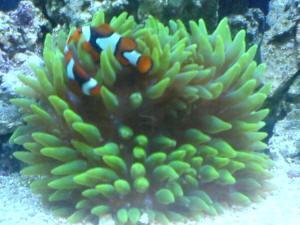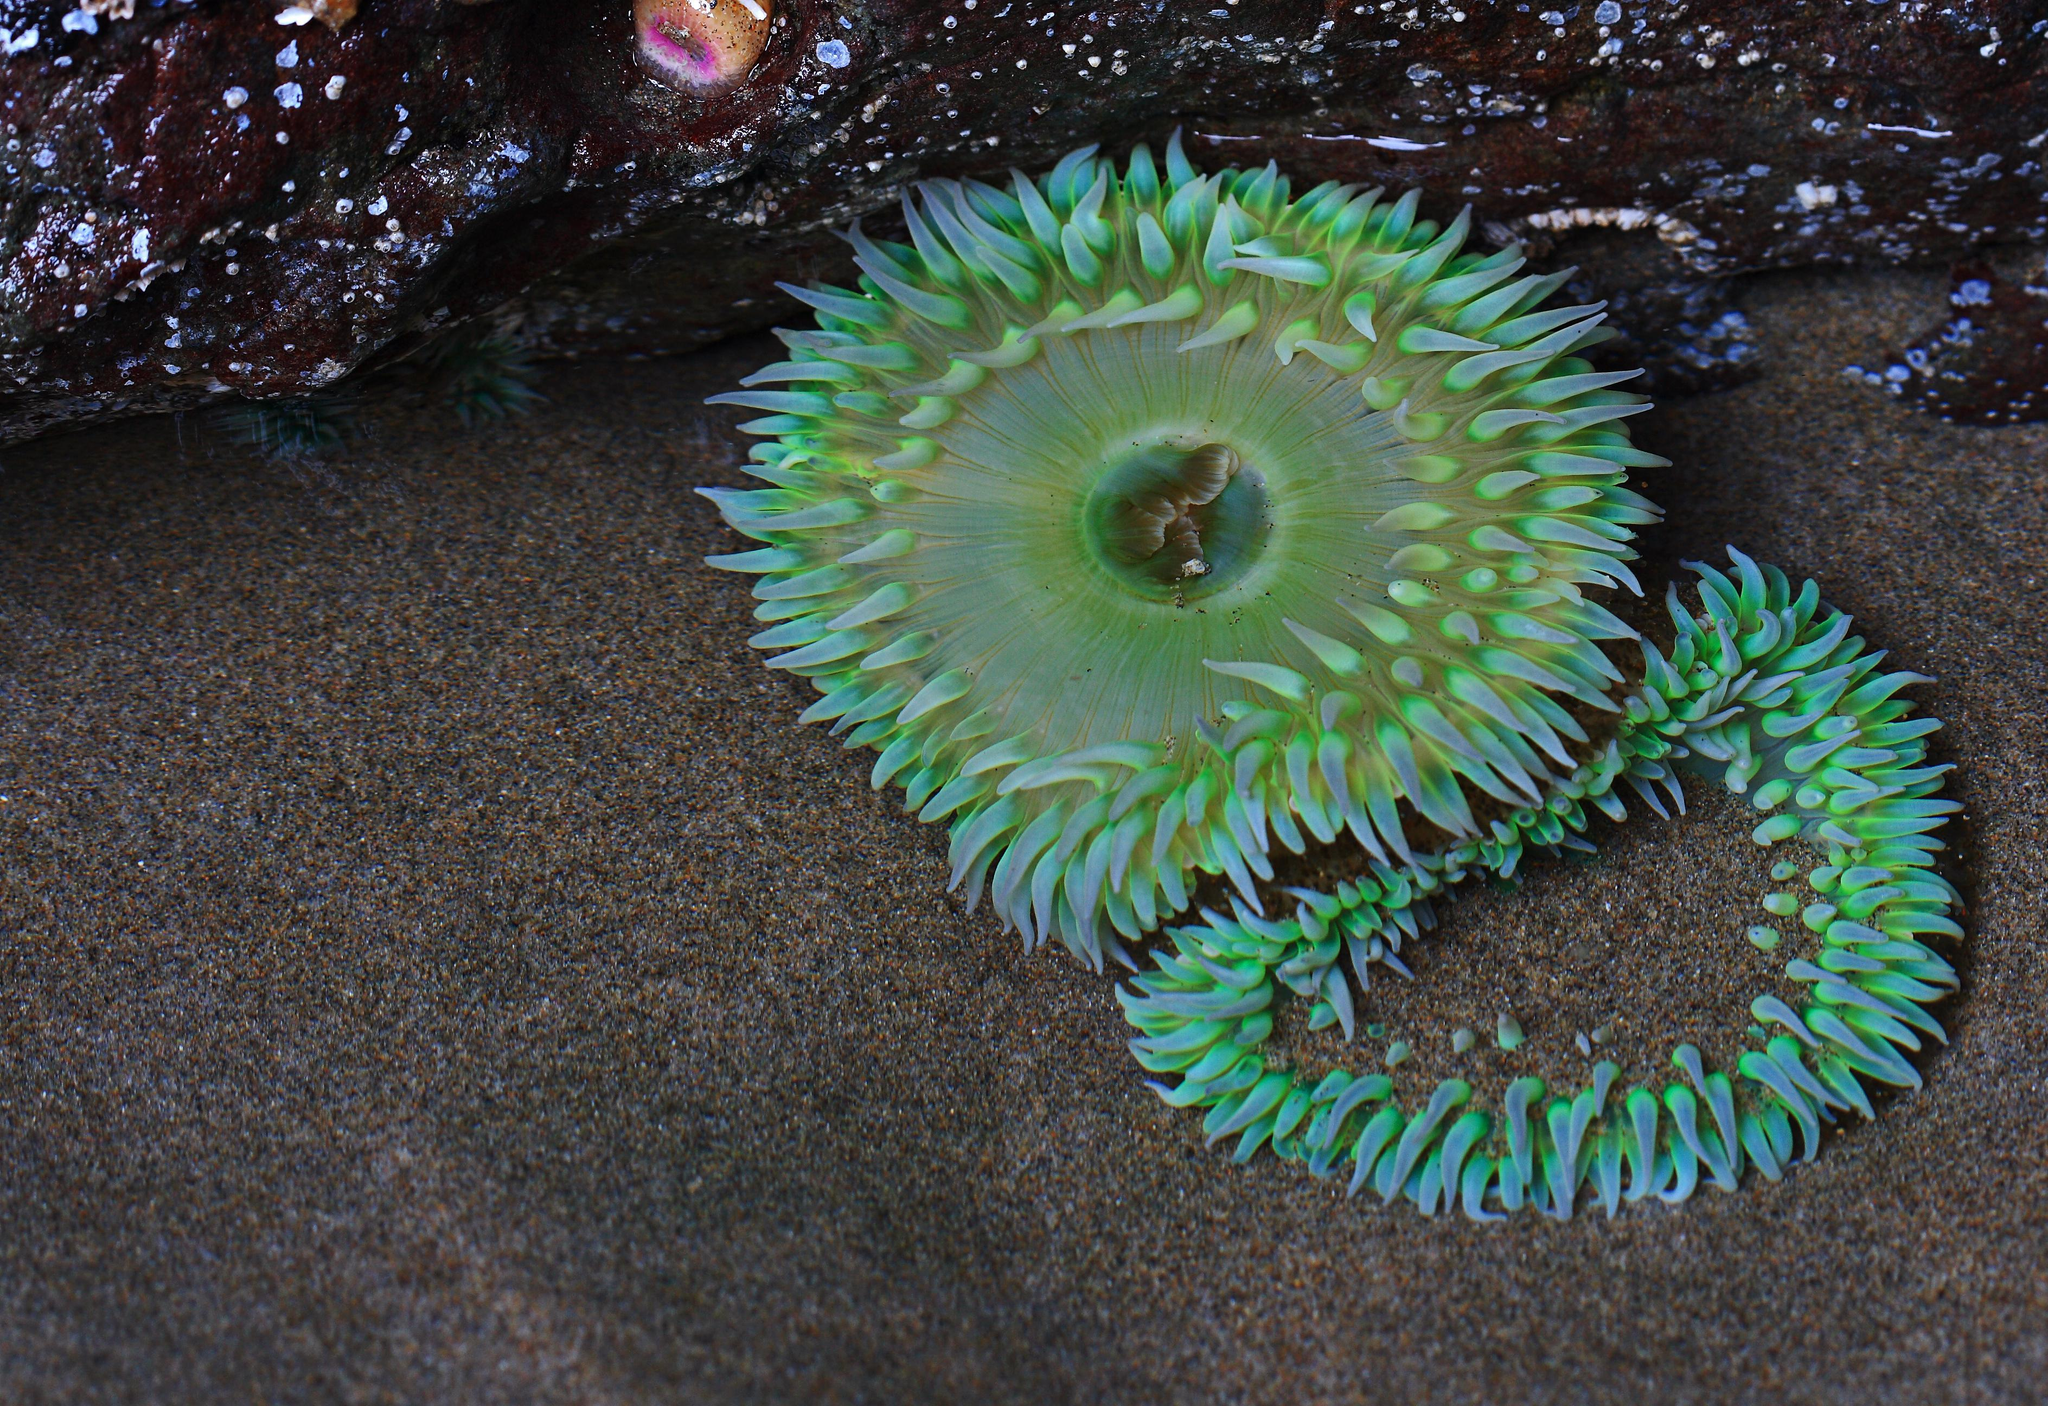The first image is the image on the left, the second image is the image on the right. Given the left and right images, does the statement "Striped clownfish are swimming in one image of an anemone." hold true? Answer yes or no. Yes. The first image is the image on the left, the second image is the image on the right. For the images displayed, is the sentence "At least one of the images contains an orange and white fish." factually correct? Answer yes or no. Yes. 